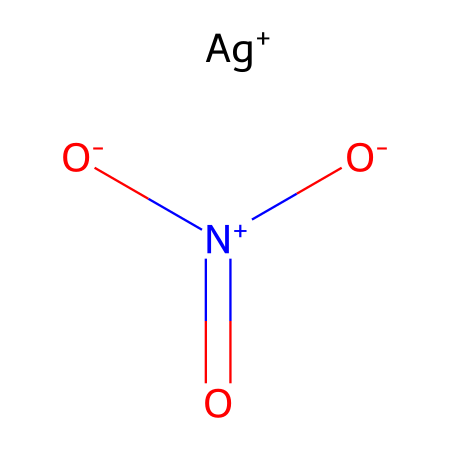What is the molecular formula of this compound? The SMILES representation indicates there are one silver atom (Ag), one nitrogen atom (N), and three oxygen atoms (O) in the structure. Therefore, combining these gives the molecular formula as AgNO3.
Answer: AgNO3 How many oxygen atoms are present in this molecule? From the SMILES representation, we can see that there are three instances of the oxygen symbol (O). This indicates that there are three oxygen atoms in total in the compound.
Answer: three What charge does the silver ion carry in this compound? The SMILES notation indicates the silver ion is represented as [Ag+], showing it carries a +1 charge.
Answer: +1 Which functional group is present in silver nitrate? In the provided SMILES, the nitrogen atom is bonded to three oxygen atoms, one of which has a double bond (N=O) while the other two are single bonded with negative charges, indicating the presence of a nitrate functional group.
Answer: nitrate What is the oxidation state of nitrogen in silver nitrate? The nitrogen atom in silver nitrate is bonded to three oxygen atoms (one with a double bond and two with single bonds). For nitrogen in such a configuration, the oxidation state can be determined to be +5.
Answer: +5 How many bonds does nitrogen have with oxygen in this molecule? The nitrogen (N) atom in silver nitrate is connected to three oxygen atoms: two through single bonds and one through a double bond. This gives a total of three bonds between nitrogen and oxygen.
Answer: three What type of compound is silver nitrate classified as? Given that silver nitrate contains a metal (silver) and nonmetals (nitrogen and oxygen), and is primarily comprised of ionic bonds between Ag+ and NO3-, it is classified as an ionic compound.
Answer: ionic compound 